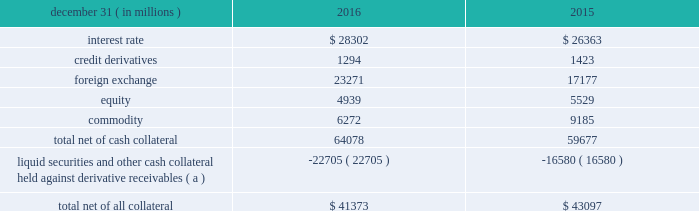Management 2019s discussion and analysis 102 jpmorgan chase & co./2016 annual report derivative contracts in the normal course of business , the firm uses derivative instruments predominantly for market-making activities .
Derivatives enable customers to manage exposures to fluctuations in interest rates , currencies and other markets .
The firm also uses derivative instruments to manage its own credit and other market risk exposure .
The nature of the counterparty and the settlement mechanism of the derivative affect the credit risk to which the firm is exposed .
For otc derivatives the firm is exposed to the credit risk of the derivative counterparty .
For exchange- traded derivatives ( 201cetd 201d ) , such as futures and options and 201ccleared 201d over-the-counter ( 201cotc-cleared 201d ) derivatives , the firm is generally exposed to the credit risk of the relevant ccp .
Where possible , the firm seeks to mitigate its credit risk exposures arising from derivative transactions through the use of legally enforceable master netting arrangements and collateral agreements .
For further discussion of derivative contracts , counterparties and settlement types , see note 6 .
The table summarizes the net derivative receivables for the periods presented .
Derivative receivables .
( a ) includes collateral related to derivative instruments where an appropriate legal opinion has not been either sought or obtained .
Derivative receivables reported on the consolidated balance sheets were $ 64.1 billion and $ 59.7 billion at december 31 , 2016 and 2015 , respectively .
These amounts represent the fair value of the derivative contracts after giving effect to legally enforceable master netting agreements and cash collateral held by the firm .
However , in management 2019s view , the appropriate measure of current credit risk should also take into consideration additional liquid securities ( primarily u.s .
Government and agency securities and other group of seven nations ( 201cg7 201d ) government bonds ) and other cash collateral held by the firm aggregating $ 22.7 billion and $ 16.6 billion at december 31 , 2016 and 2015 , respectively , that may be used as security when the fair value of the client 2019s exposure is in the firm 2019s favor .
The change in derivative receivables was predominantly related to client-driven market-making activities in cib .
The increase in derivative receivables reflected the impact of market movements , which increased foreign exchange receivables , partially offset by reduced commodity derivative receivables .
In addition to the collateral described in the preceding paragraph , the firm also holds additional collateral ( primarily cash , g7 government securities , other liquid government-agency and guaranteed securities , and corporate debt and equity securities ) delivered by clients at the initiation of transactions , as well as collateral related to contracts that have a non-daily call frequency and collateral that the firm has agreed to return but has not yet settled as of the reporting date .
Although this collateral does not reduce the balances and is not included in the table above , it is available as security against potential exposure that could arise should the fair value of the client 2019s derivative transactions move in the firm 2019s favor .
The derivative receivables fair value , net of all collateral , also does not include other credit enhancements , such as letters of credit .
For additional information on the firm 2019s use of collateral agreements , see note 6 .
While useful as a current view of credit exposure , the net fair value of the derivative receivables does not capture the potential future variability of that credit exposure .
To capture the potential future variability of credit exposure , the firm calculates , on a client-by-client basis , three measures of potential derivatives-related credit loss : peak , derivative risk equivalent ( 201cdre 201d ) , and average exposure ( 201cavg 201d ) .
These measures all incorporate netting and collateral benefits , where applicable .
Peak represents a conservative measure of potential exposure to a counterparty calculated in a manner that is broadly equivalent to a 97.5% ( 97.5 % ) confidence level over the life of the transaction .
Peak is the primary measure used by the firm for setting of credit limits for derivative transactions , senior management reporting and derivatives exposure management .
Dre exposure is a measure that expresses the risk of derivative exposure on a basis intended to be equivalent to the risk of loan exposures .
Dre is a less extreme measure of potential credit loss than peak and is used for aggregating derivative credit risk exposures with loans and other credit risk .
Finally , avg is a measure of the expected fair value of the firm 2019s derivative receivables at future time periods , including the benefit of collateral .
Avg exposure over the total life of the derivative contract is used as the primary metric for pricing purposes and is used to calculate credit capital and the cva , as further described below .
The three year avg exposure was $ 31.1 billion and $ 32.4 billion at december 31 , 2016 and 2015 , respectively , compared with derivative receivables , net of all collateral , of $ 41.4 billion and $ 43.1 billion at december 31 , 2016 and 2015 , respectively .
The fair value of the firm 2019s derivative receivables incorporates an adjustment , the cva , to reflect the credit quality of counterparties .
The cva is based on the firm 2019s avg to a counterparty and the counterparty 2019s credit spread in the credit derivatives market .
The primary components of changes in cva are credit spreads , new deal activity or unwinds , and changes in the underlying market environment .
The firm believes that active risk management is essential to controlling the dynamic credit .
Based on the review of the net derivative receivables for the periods what was the ratio of the foreign exchange in 2016 to 2015? 
Computations: (23271 / 17177)
Answer: 1.35478. 